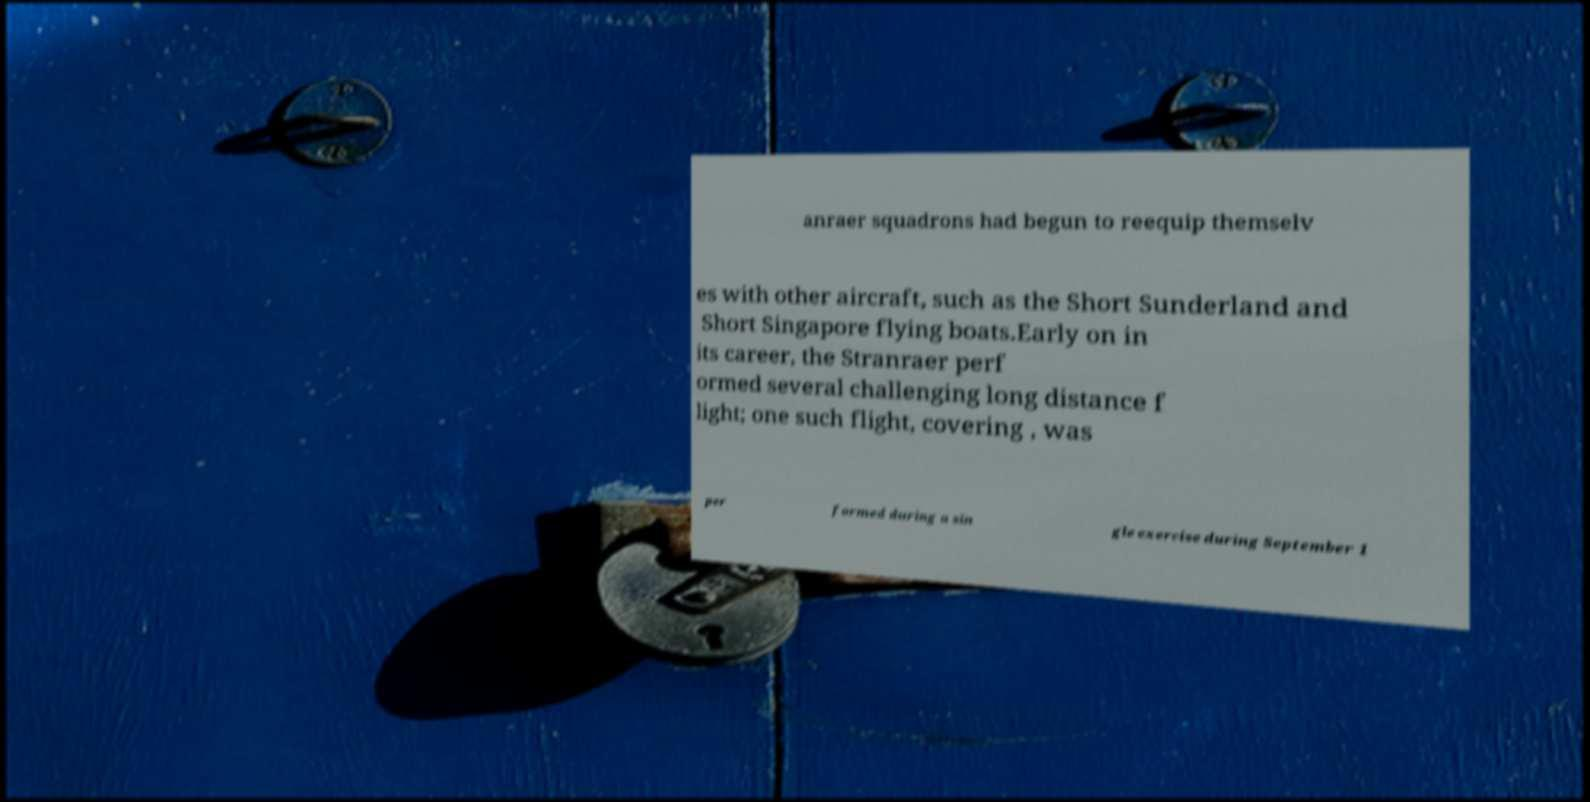There's text embedded in this image that I need extracted. Can you transcribe it verbatim? anraer squadrons had begun to reequip themselv es with other aircraft, such as the Short Sunderland and Short Singapore flying boats.Early on in its career, the Stranraer perf ormed several challenging long distance f light; one such flight, covering , was per formed during a sin gle exercise during September 1 